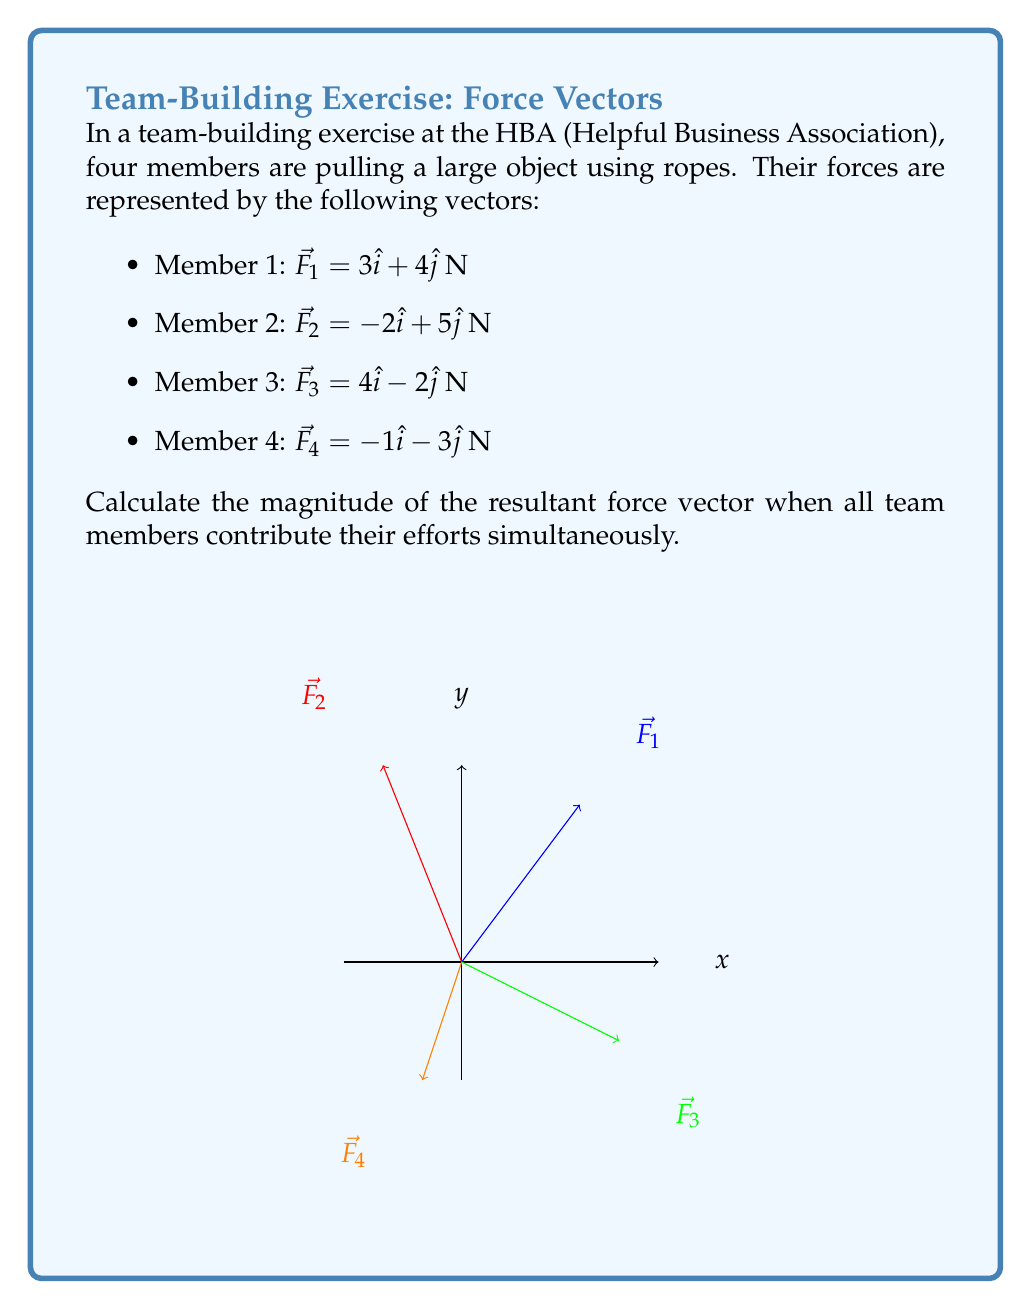Teach me how to tackle this problem. To calculate the resultant force vector, we need to add all the individual force vectors together and then find the magnitude of the resultant.

Step 1: Add the x-components and y-components of all vectors.

$\sum F_x = 3 + (-2) + 4 + (-1) = 4$ N
$\sum F_y = 4 + 5 + (-2) + (-3) = 4$ N

Step 2: Express the resultant vector $\vec{R}$ in component form.

$\vec{R} = 4\hat{i} + 4\hat{j}$ N

Step 3: Calculate the magnitude of the resultant vector using the Pythagorean theorem.

$$|\vec{R}| = \sqrt{(\sum F_x)^2 + (\sum F_y)^2}$$
$$|\vec{R}| = \sqrt{4^2 + 4^2}$$
$$|\vec{R}| = \sqrt{32}$$
$$|\vec{R}| = 4\sqrt{2}$$ N

Therefore, the magnitude of the resultant force vector is $4\sqrt{2}$ N.
Answer: $4\sqrt{2}$ N 